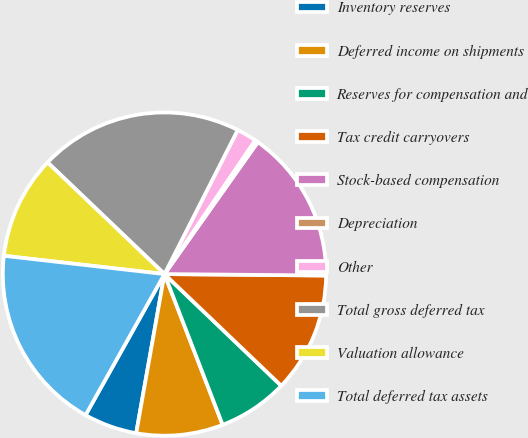<chart> <loc_0><loc_0><loc_500><loc_500><pie_chart><fcel>Inventory reserves<fcel>Deferred income on shipments<fcel>Reserves for compensation and<fcel>Tax credit carryovers<fcel>Stock-based compensation<fcel>Depreciation<fcel>Other<fcel>Total gross deferred tax<fcel>Valuation allowance<fcel>Total deferred tax assets<nl><fcel>5.32%<fcel>8.66%<fcel>6.99%<fcel>12.0%<fcel>15.34%<fcel>0.32%<fcel>1.99%<fcel>20.35%<fcel>10.33%<fcel>18.68%<nl></chart> 